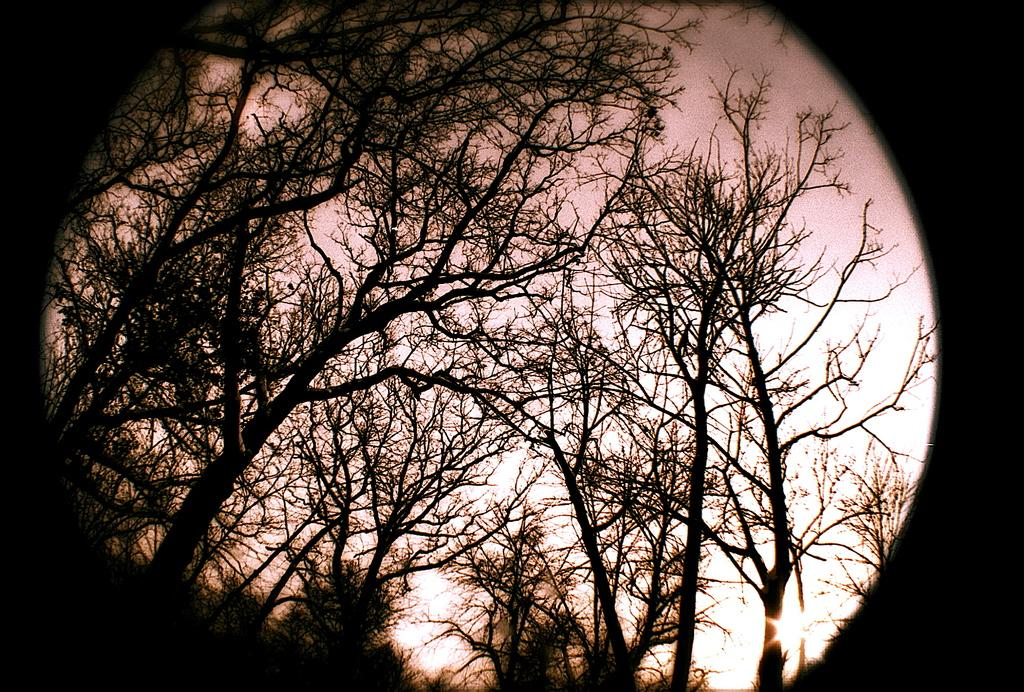What type of vegetation can be seen in the image? There is a group of trees in the image. What else is visible in the image besides the trees? The sky is visible in the image. What type of stick is the horse using for digestion in the image? There is no horse or stick present in the image; it only features a group of trees and the sky. 